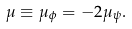<formula> <loc_0><loc_0><loc_500><loc_500>\mu \equiv \mu _ { \phi } = - 2 \mu _ { \psi } .</formula> 